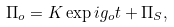<formula> <loc_0><loc_0><loc_500><loc_500>\Pi _ { o } = K \exp { i g _ { o } t } + \Pi _ { S } ,</formula> 